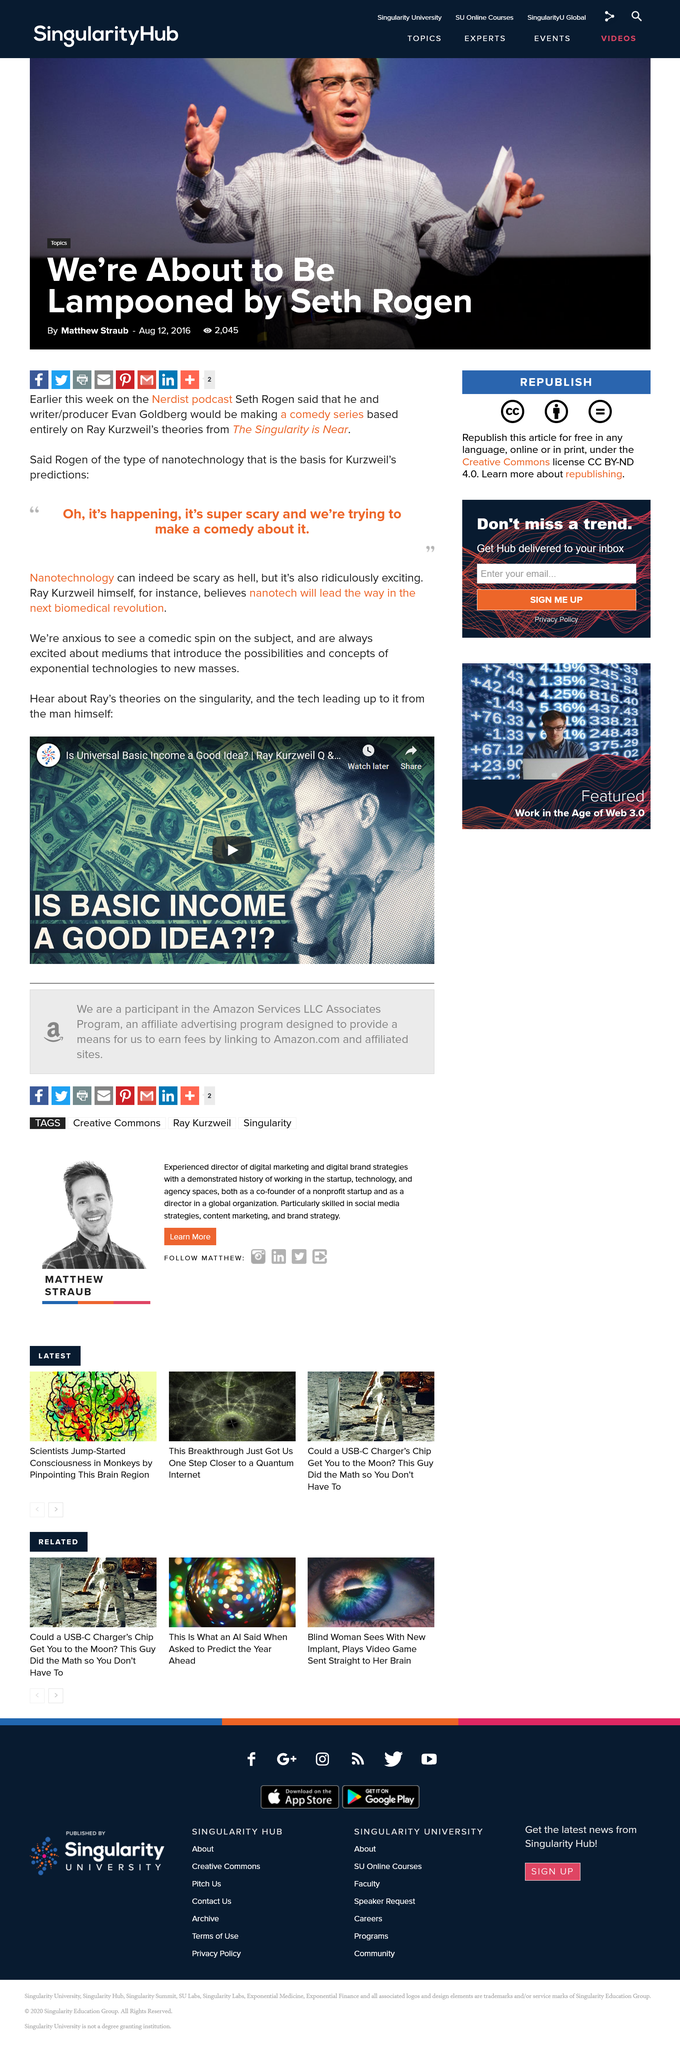Mention a couple of crucial points in this snapshot. The video "Is Universal Basic Income a Good Idea?" is shareable. Seth Rogen announced that he will be making a comedy series based on Ray Kurzweil's theories. Ray Kurzweil is featured in the video. 